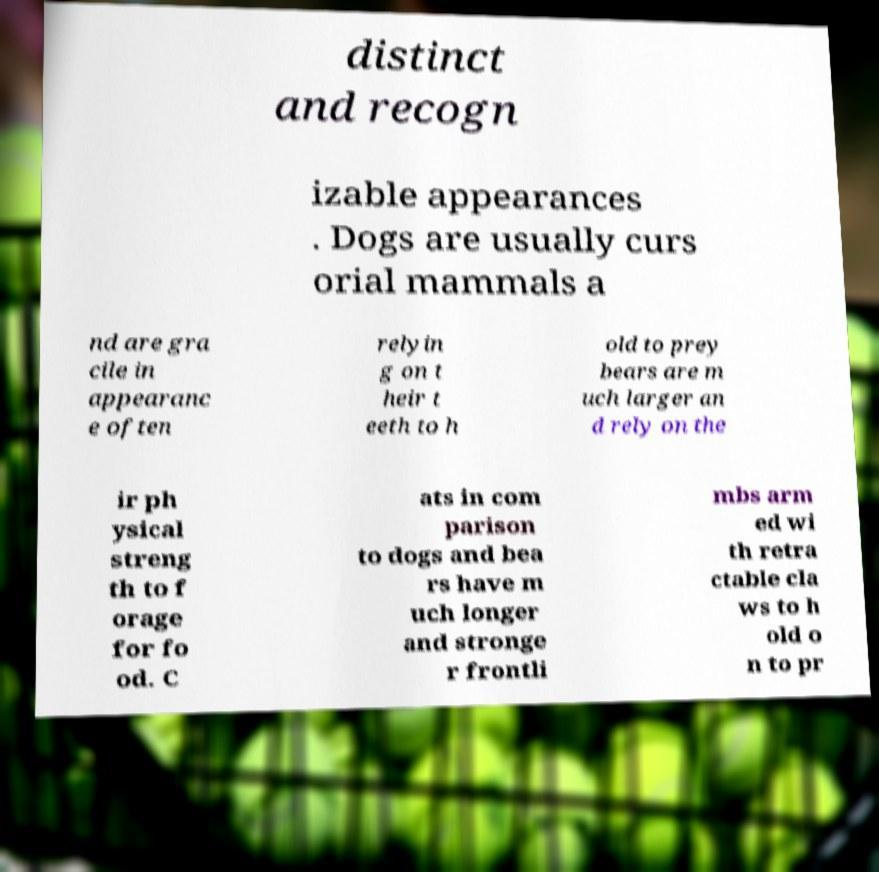There's text embedded in this image that I need extracted. Can you transcribe it verbatim? distinct and recogn izable appearances . Dogs are usually curs orial mammals a nd are gra cile in appearanc e often relyin g on t heir t eeth to h old to prey bears are m uch larger an d rely on the ir ph ysical streng th to f orage for fo od. C ats in com parison to dogs and bea rs have m uch longer and stronge r frontli mbs arm ed wi th retra ctable cla ws to h old o n to pr 